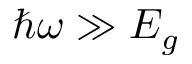<formula> <loc_0><loc_0><loc_500><loc_500>\hbar { \omega } \gg E _ { g }</formula> 